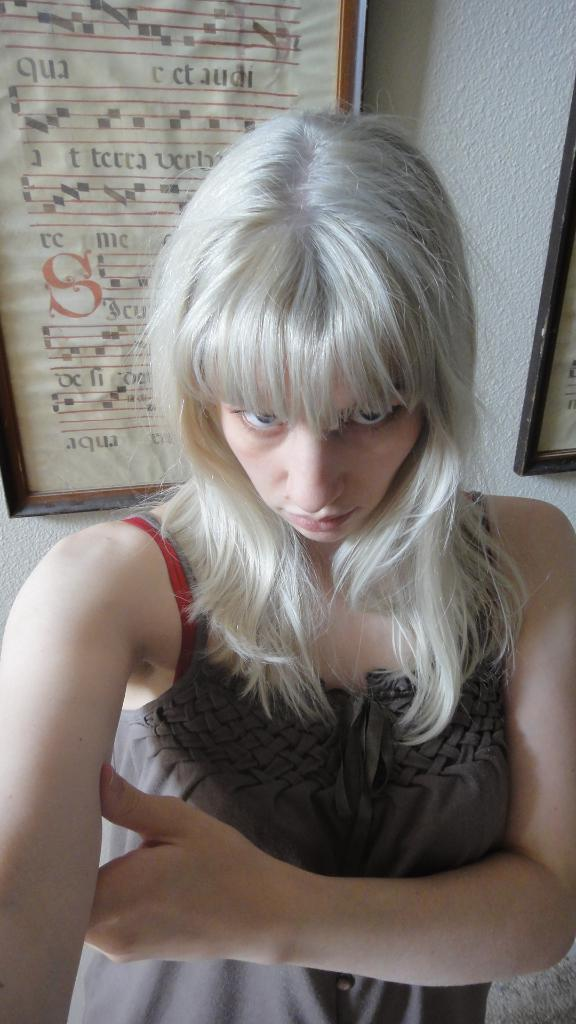Who is the main subject in the front portion of the image? There is a woman in the front portion of the image. What can be seen in the background of the image? There is a wall in the background of the image. What is on the wall in the background? There are pictures on the wall in the background. What type of rifle is the woman holding in the image? There is no rifle present in the image; the woman is not holding any object. 